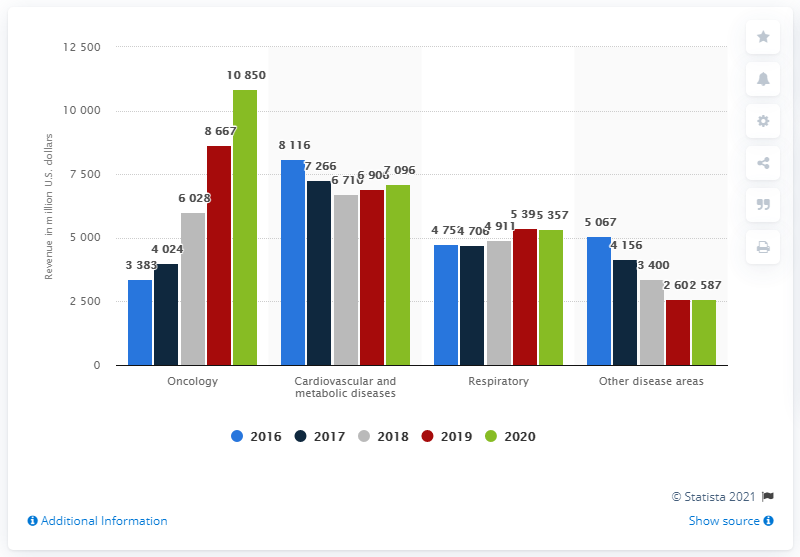Point out several critical features in this image. In 2020, AstraZeneca's oncology revenue was approximately 10,850 million U.S. dollars. 